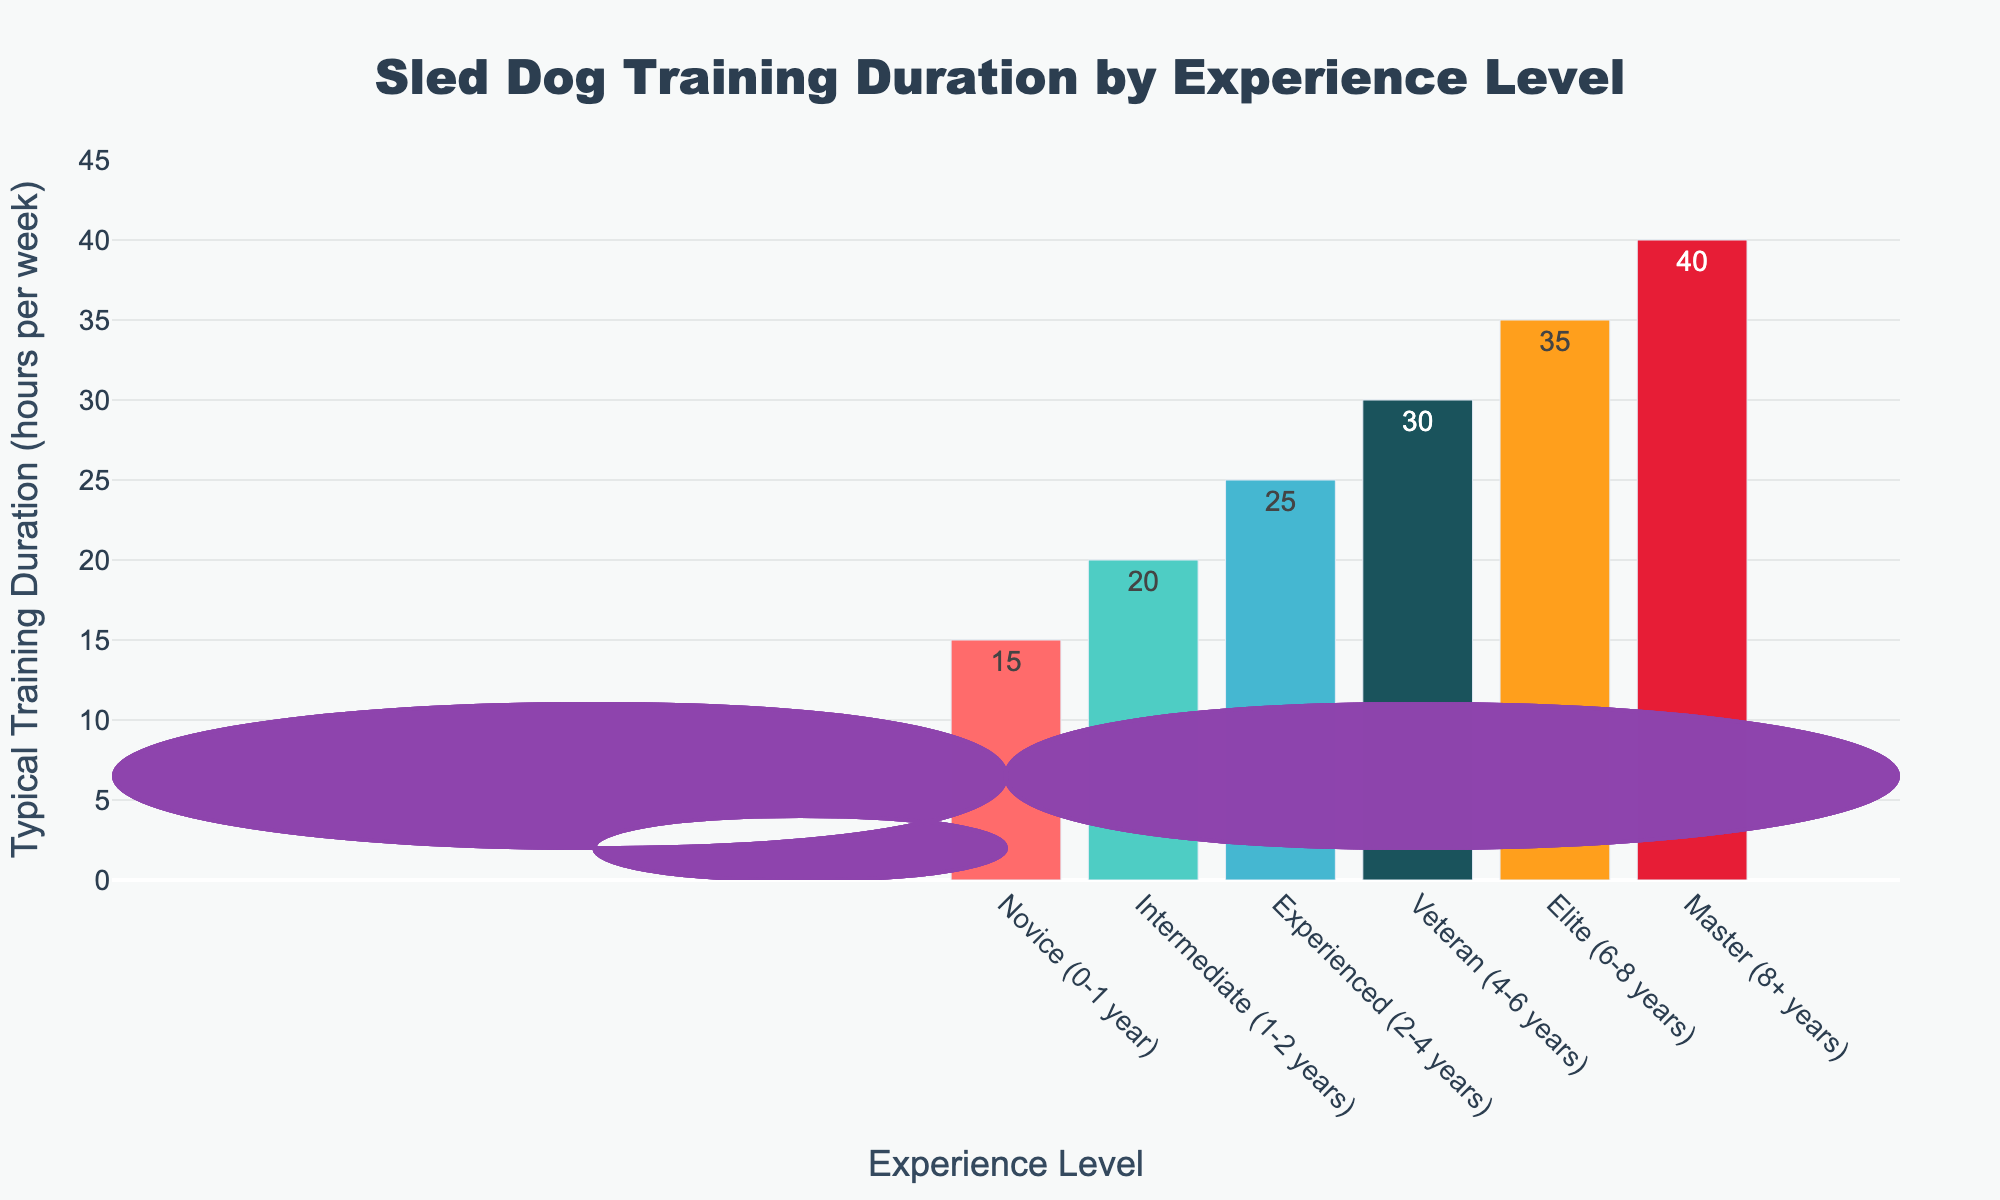What is the typical training duration for a novice sled dog? The novice sled dogs have their training duration mentioned as one of the data points in the figure. By looking at the bar representing novice dogs, we can see that the height of the bar is aligned with the value 15 on the y-axis.
Answer: 15 hours Which experience level of sled dogs has the highest training duration? The experience level with the highest training duration can be determined by identifying the tallest bar in the chart. The tallest bar represents the master level, indicating a training duration of 40 hours.
Answer: Master (8+ years) How much more is the typical training duration for experienced sled dogs compared to novice sled dogs? To find the difference in training durations, subtract the value for novice dogs from the value for experienced dogs. The novice dogs train 15 hours while experienced dogs train 25 hours. So, 25 - 15 = 10 hours.
Answer: 10 hours Which levels of sled dogs have a training duration greater than 30 hours? By scanning the chart and checking the heights of each bar, find the bars that extend beyond the 30-hour mark on the y-axis. The levels with training durations greater than 30 hours are Elite and Master.
Answer: Elite (6-8 years) and Master (8+ years) What is the average training duration of novice, intermediate, and experienced sled dogs combined? To find the average, sum the training durations for novice, intermediate, and experienced sled dogs, and then divide by the number of levels. The sum is 15 (novice) + 20 (intermediate) + 25 (experienced) = 60. There are 3 levels, so 60 / 3 = 20 hours.
Answer: 20 hours Is the training duration for veteran sled dogs equal to the training duration for intermediate and novice sled dogs combined? First, add the training durations for intermediate and novice sled dogs: 20 (intermediate) + 15 (novice) = 35. Then, compare this to the training duration for the veteran level, which is 30 hours. Thus, 35 is not equal to 30.
Answer: No Which bar in the chart is colored orange, and what is the training duration for that experience level? By observing the colors of the bars, the orange-colored bar corresponds to the veteran level. The veteran level has a training duration of 30 hours.
Answer: Veteran (4-6 years), 30 hours How does the training duration of elite sled dogs compare to that of novice sled dogs? To compare, subtract the training duration of novice dogs from that of elite dogs, and determine if the result is positive. The elite sled dogs train 35 hours, while novice sled dogs train 15 hours. So, 35 - 15 = 20 hours more.
Answer: 20 hours more What is the progression of typical training durations from novice to master levels? Read the durations from the chart in sequence from novice to master: Novice (15 hours), Intermediate (20 hours), Experienced (25 hours), Veteran (30 hours), Elite (35 hours), Master (40 hours). The progression shows a steady increase in training duration with experience.
Answer: 15, 20, 25, 30, 35, 40 